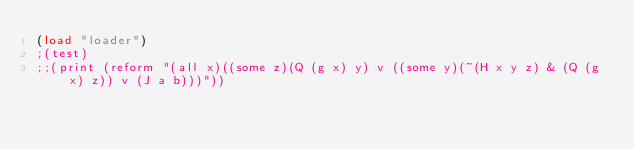<code> <loc_0><loc_0><loc_500><loc_500><_Lisp_>(load "loader")
;(test)
;;(print (reform "(all x)((some z)(Q (g x) y) v ((some y)(~(H x y z) & (Q (g x) z)) v (J a b)))"))</code> 